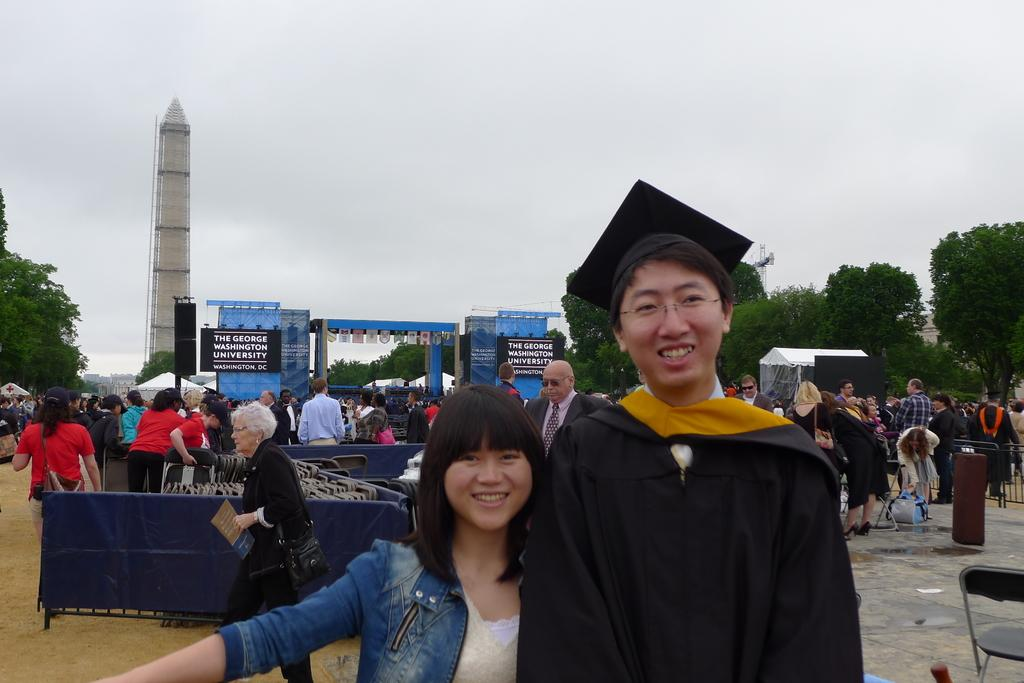Who is present in the image? There is a man and a woman in the image. What are the man and woman doing in the image? The man and woman are kissing a photo. Can you describe the background of the image? There are people in the background doing different activities, trees, a tower, and a cloudy sky. What type of guide is the hen holding in the image? There is no hen or guide present in the image. 